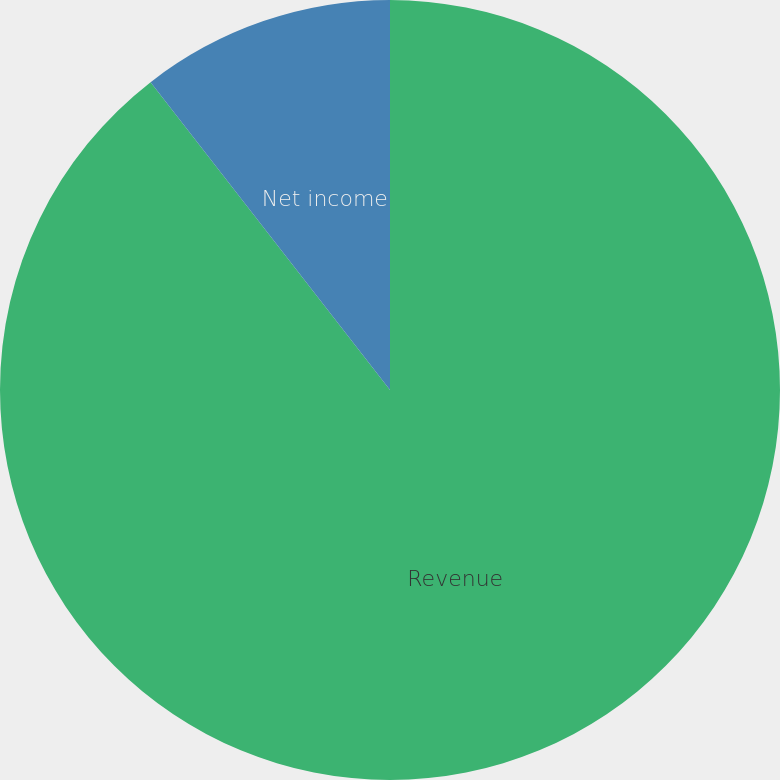<chart> <loc_0><loc_0><loc_500><loc_500><pie_chart><fcel>Revenue<fcel>Net income<fcel>Diluted earnings per common<nl><fcel>89.48%<fcel>10.52%<fcel>0.0%<nl></chart> 